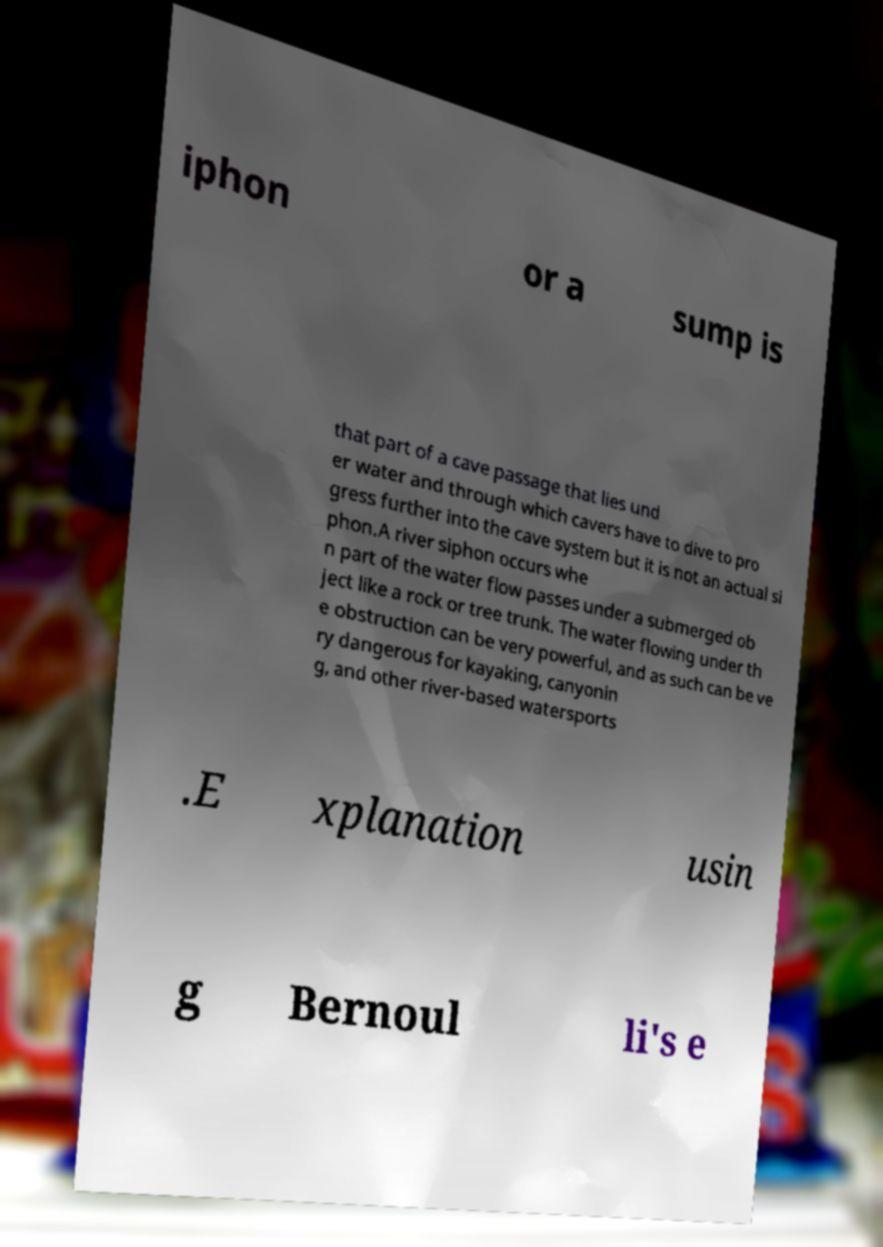Can you accurately transcribe the text from the provided image for me? iphon or a sump is that part of a cave passage that lies und er water and through which cavers have to dive to pro gress further into the cave system but it is not an actual si phon.A river siphon occurs whe n part of the water flow passes under a submerged ob ject like a rock or tree trunk. The water flowing under th e obstruction can be very powerful, and as such can be ve ry dangerous for kayaking, canyonin g, and other river-based watersports .E xplanation usin g Bernoul li's e 